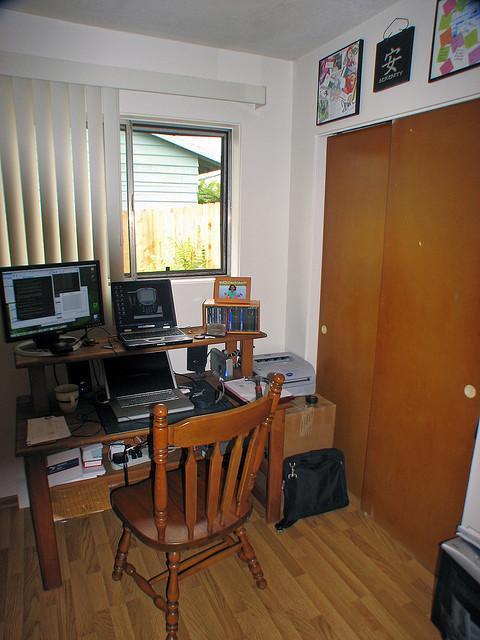How many computers are there?
Give a very brief answer. 3. How many boxes are there?
Give a very brief answer. 1. How many chairs are at the table?
Give a very brief answer. 1. How many laptops are there?
Give a very brief answer. 2. How many tvs can be seen?
Give a very brief answer. 3. 